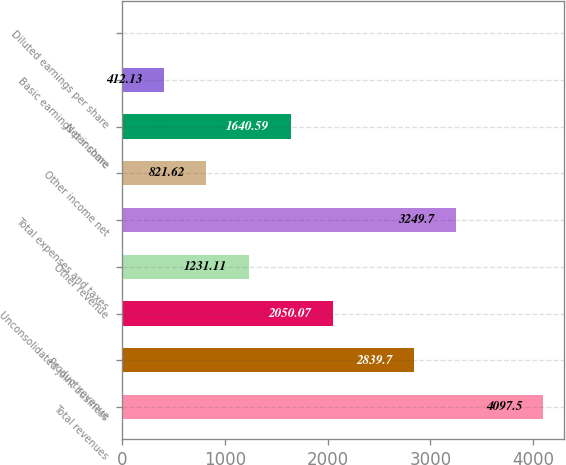Convert chart. <chart><loc_0><loc_0><loc_500><loc_500><bar_chart><fcel>Total revenues<fcel>Product revenue<fcel>Unconsolidated joint business<fcel>Other revenue<fcel>Total expenses and taxes<fcel>Other income net<fcel>Net income<fcel>Basic earnings per share<fcel>Diluted earnings per share<nl><fcel>4097.5<fcel>2839.7<fcel>2050.07<fcel>1231.11<fcel>3249.7<fcel>821.62<fcel>1640.59<fcel>412.13<fcel>2.65<nl></chart> 